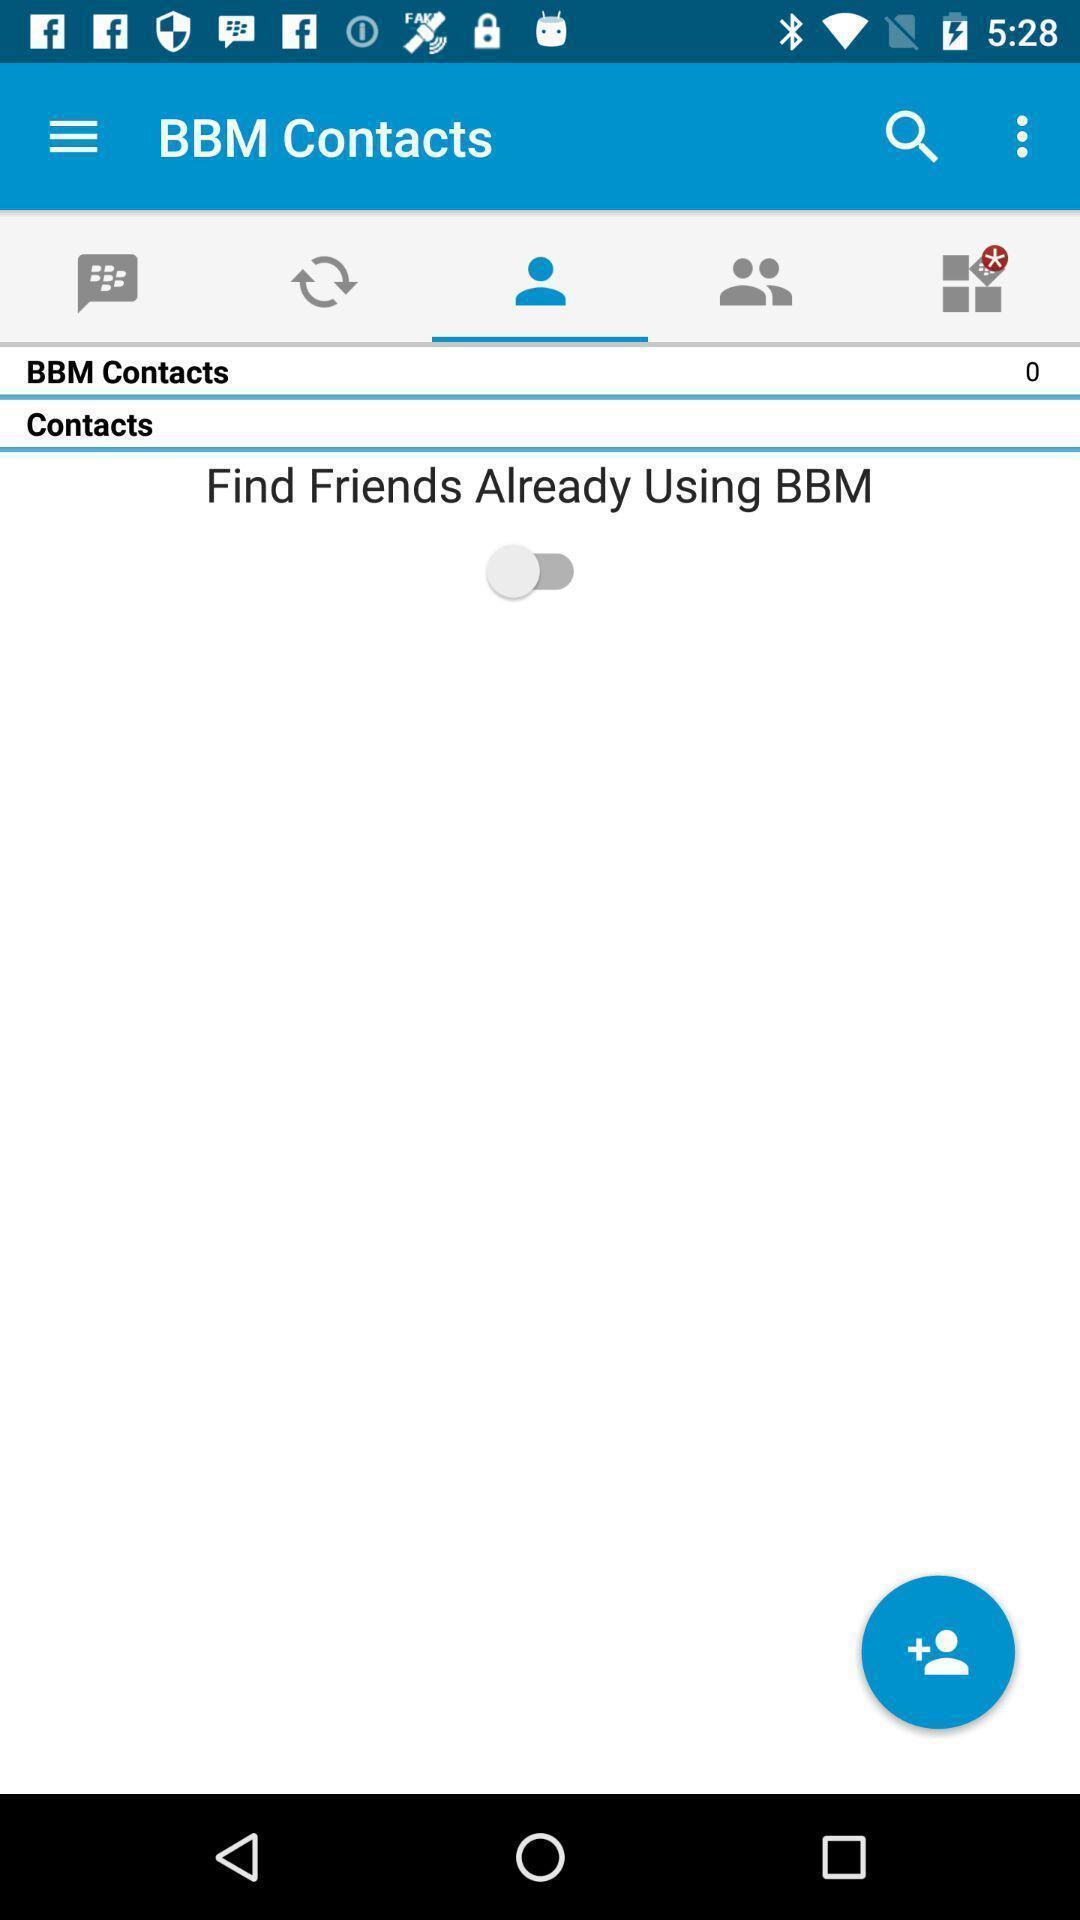Provide a textual representation of this image. List of options available in the app. 